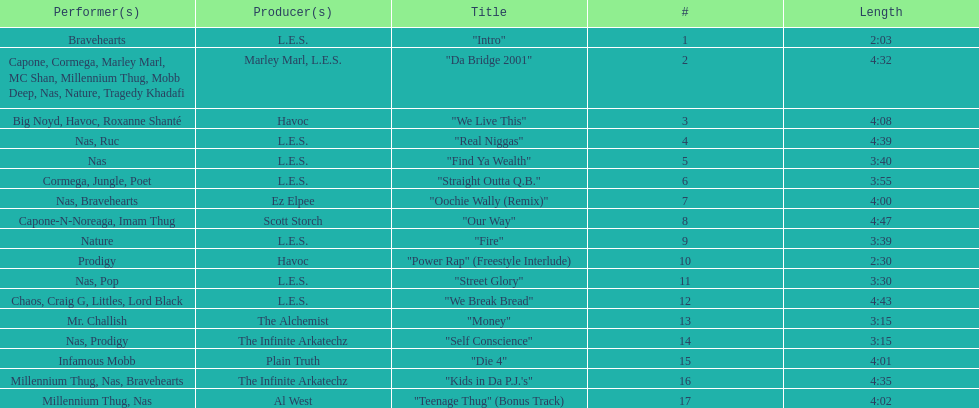Who produced the last track of the album? Al West. 